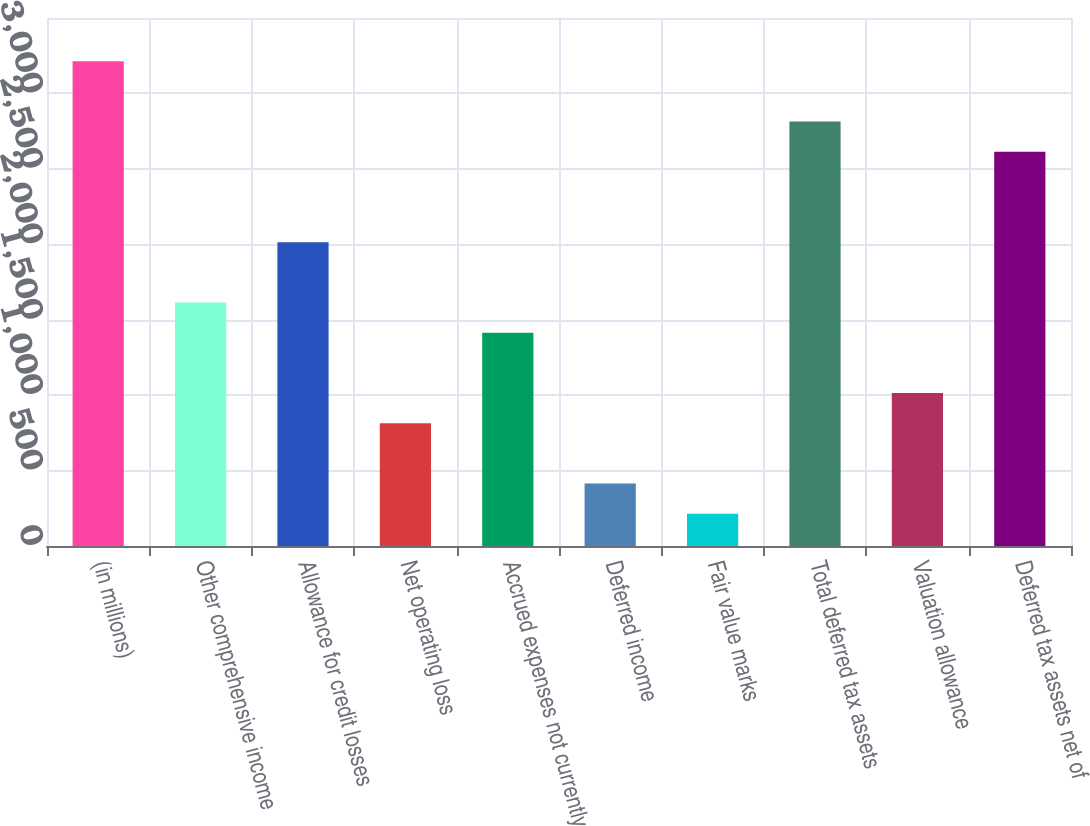Convert chart to OTSL. <chart><loc_0><loc_0><loc_500><loc_500><bar_chart><fcel>(in millions)<fcel>Other comprehensive income<fcel>Allowance for credit losses<fcel>Net operating loss<fcel>Accrued expenses not currently<fcel>Deferred income<fcel>Fair value marks<fcel>Total deferred tax assets<fcel>Valuation allowance<fcel>Deferred tax assets net of<nl><fcel>3214<fcel>1614<fcel>2014<fcel>814<fcel>1414<fcel>414<fcel>214<fcel>2814<fcel>1014<fcel>2614<nl></chart> 